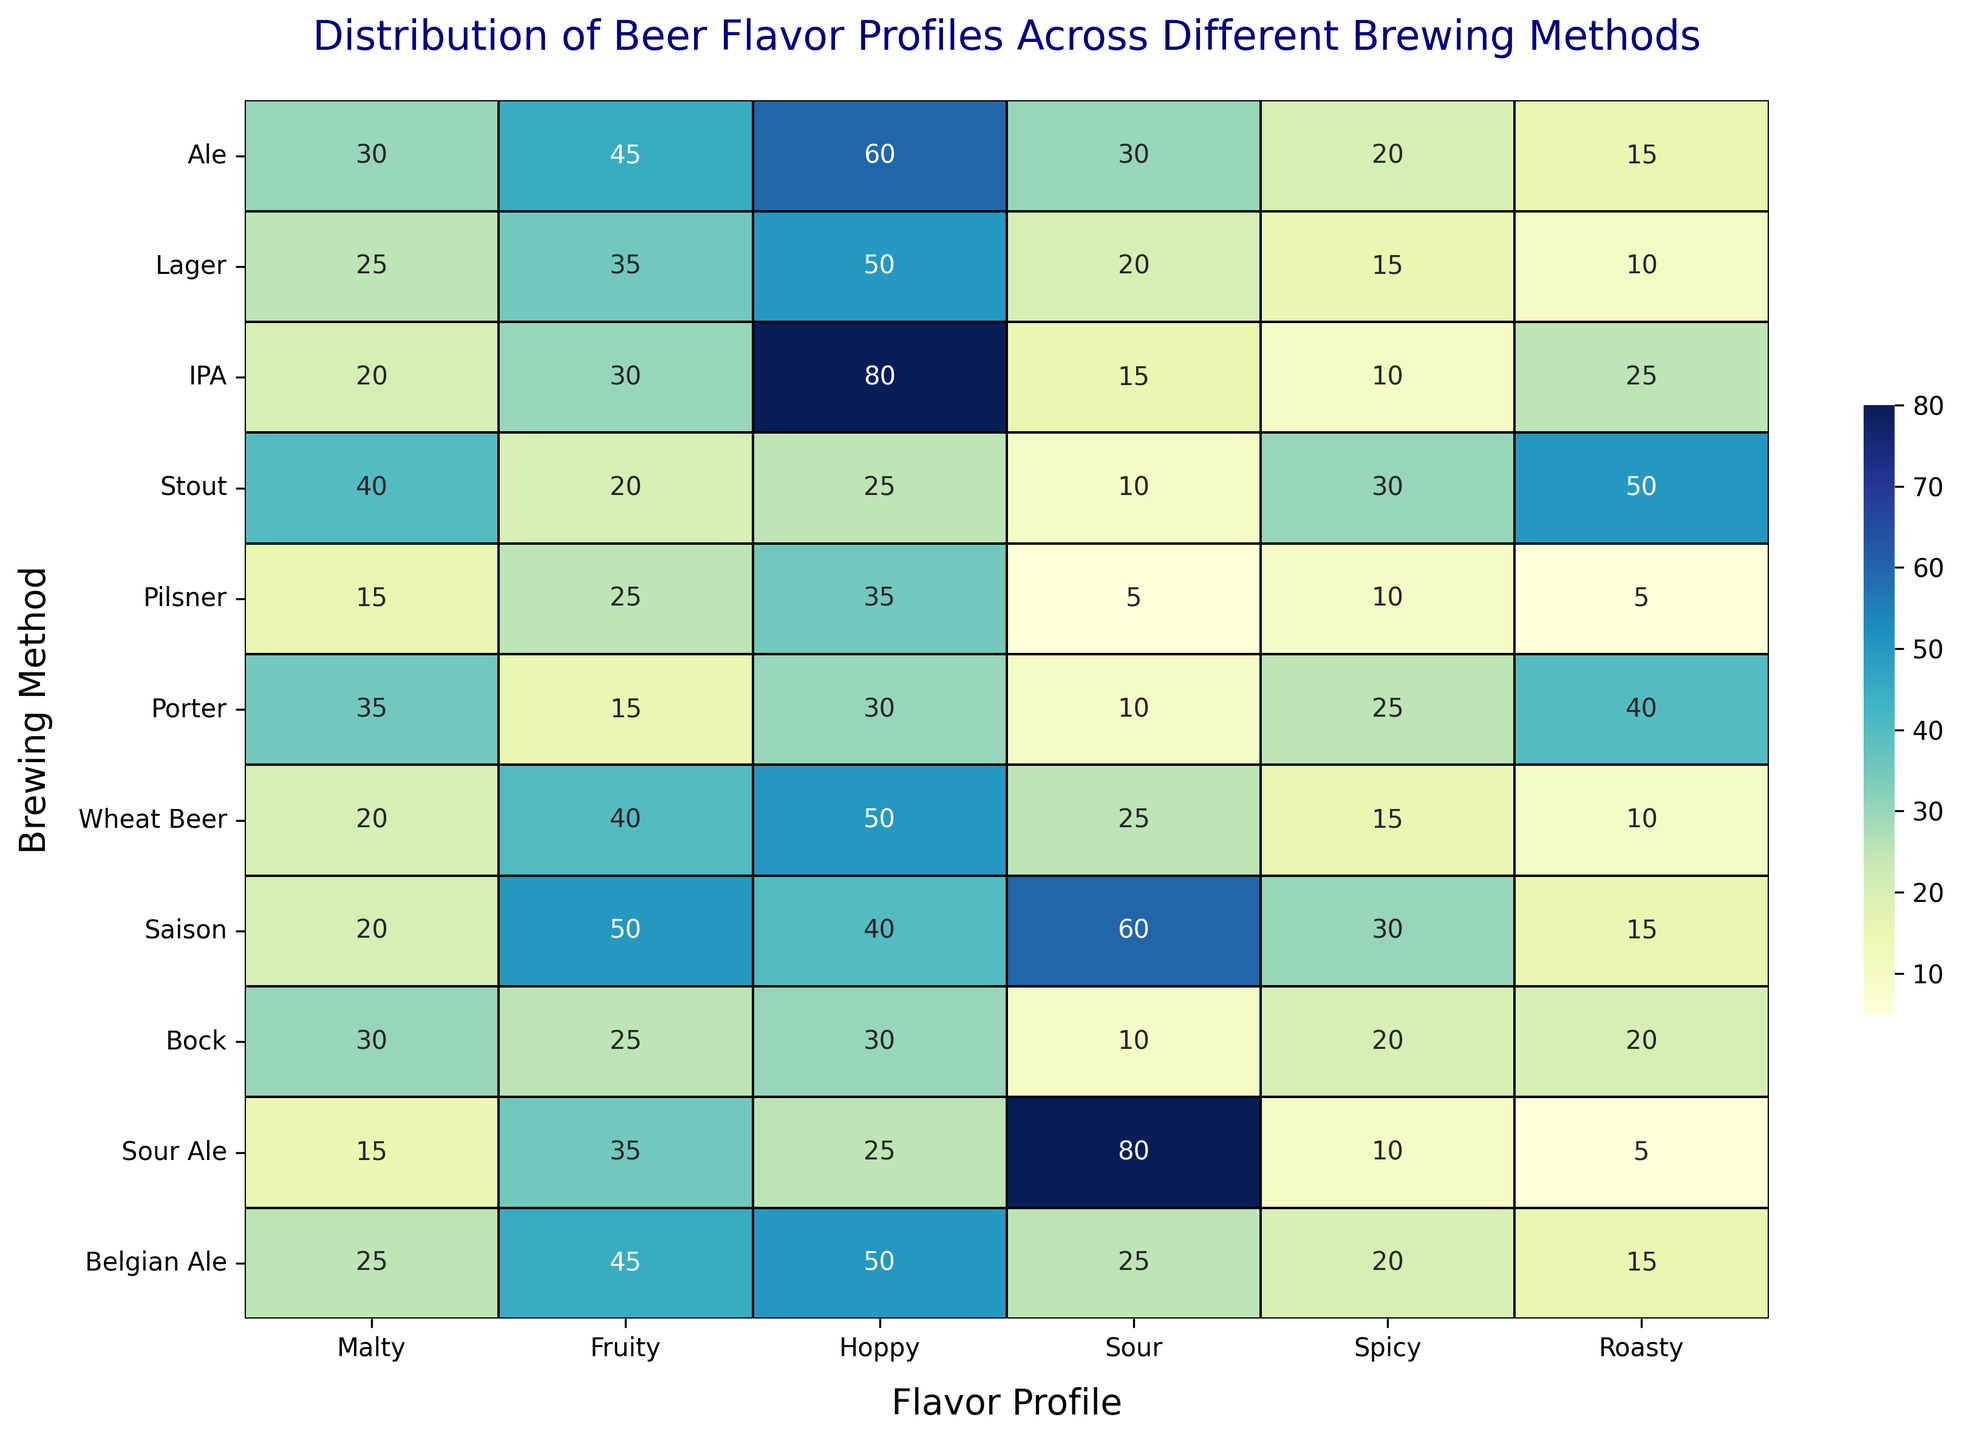What's the brewing method with the highest score in the "Hoppy" flavor profile? To find this, locate the "Hoppy" column and identify the brewing method with the highest value. For "Hoppy", the highest score is 80, which corresponds to "IPA".
Answer: IPA Which brewing method has the lowest combined score of "Malty" and "Roasty"? Add the scores of "Malty" and "Roasty" for each brewing method. The combined scores for each are: Ale (45), Lager (35), IPA (45), Stout (90), Pilsner (20), Porter (75), Wheat Beer (30), Saison (35), Bock (50), Sour Ale (20), Belgian Ale (40). The lowest combined score is 20, found in "Pilsner" and "Sour Ale".
Answer: Pilsner, Sour Ale Which brewing method has the most evenly distributed scores across all flavor profiles? Analyzing the flavor profiles for each brewing method, we look for the method with scores that have the least deviation from one another. "Belgian Ale" has fairly even scores: 25, 45, 50, 25, 20, 15.
Answer: Belgian Ale Among the brewing methods, which two have the greatest difference in their "Sour" flavor profile scores? The highest "Sour" score is 80 (Sour Ale), and the lowest is 5 (Pilsner). The difference between these two is 80 - 5 = 75.
Answer: Sour Ale and Pilsner Which brewing method is associated with the highest score in the "Roasty" flavor profile, and what is that score? Look at the "Roasty" column and find the highest value, which is 50 for "Stout".
Answer: Stout, 50 Which brewing methods have the same score for the "Spicy" flavor profile? Check the "Spicy" column for repeated values. "Ale" and "Belgian Ale" both have a score of 20.
Answer: Ale, Belgian Ale What is the sum of the "Fruity" flavor profile scores for "Ale" and "Saison"? Add the "Fruity" scores of Ale (45) and Saison (50) together: 45 + 50 = 95.
Answer: 95 Which brewing method has the second highest score in the "Fruity" flavor profile? The highest "Fruity" score is 50 (Saison), and the second highest is 45, which both Ale and Belgian Ale have.
Answer: Ale, Belgian Ale What is the total number of brewing methods with a "Roasty" score greater than or equal to 20? Count the brewing methods with "Roasty" scores of 20 or more: Ale (15), Lager (10), IPA (25), Stout (50), Pilsner (5), Porter (40), Wheat Beer (10), Saison (15), Bock (20), Sour Ale (5), Belgian Ale (15). The count is 5 (IPA, Stout, Porter, Bock, Ale).
Answer: 5 